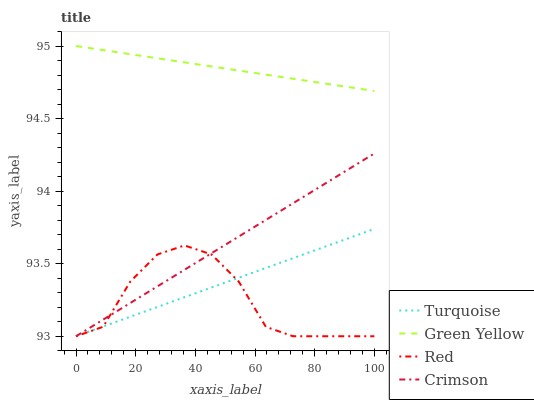Does Red have the minimum area under the curve?
Answer yes or no. Yes. Does Green Yellow have the maximum area under the curve?
Answer yes or no. Yes. Does Turquoise have the minimum area under the curve?
Answer yes or no. No. Does Turquoise have the maximum area under the curve?
Answer yes or no. No. Is Green Yellow the smoothest?
Answer yes or no. Yes. Is Red the roughest?
Answer yes or no. Yes. Is Turquoise the smoothest?
Answer yes or no. No. Is Turquoise the roughest?
Answer yes or no. No. Does Crimson have the lowest value?
Answer yes or no. Yes. Does Green Yellow have the lowest value?
Answer yes or no. No. Does Green Yellow have the highest value?
Answer yes or no. Yes. Does Turquoise have the highest value?
Answer yes or no. No. Is Turquoise less than Green Yellow?
Answer yes or no. Yes. Is Green Yellow greater than Turquoise?
Answer yes or no. Yes. Does Turquoise intersect Red?
Answer yes or no. Yes. Is Turquoise less than Red?
Answer yes or no. No. Is Turquoise greater than Red?
Answer yes or no. No. Does Turquoise intersect Green Yellow?
Answer yes or no. No. 